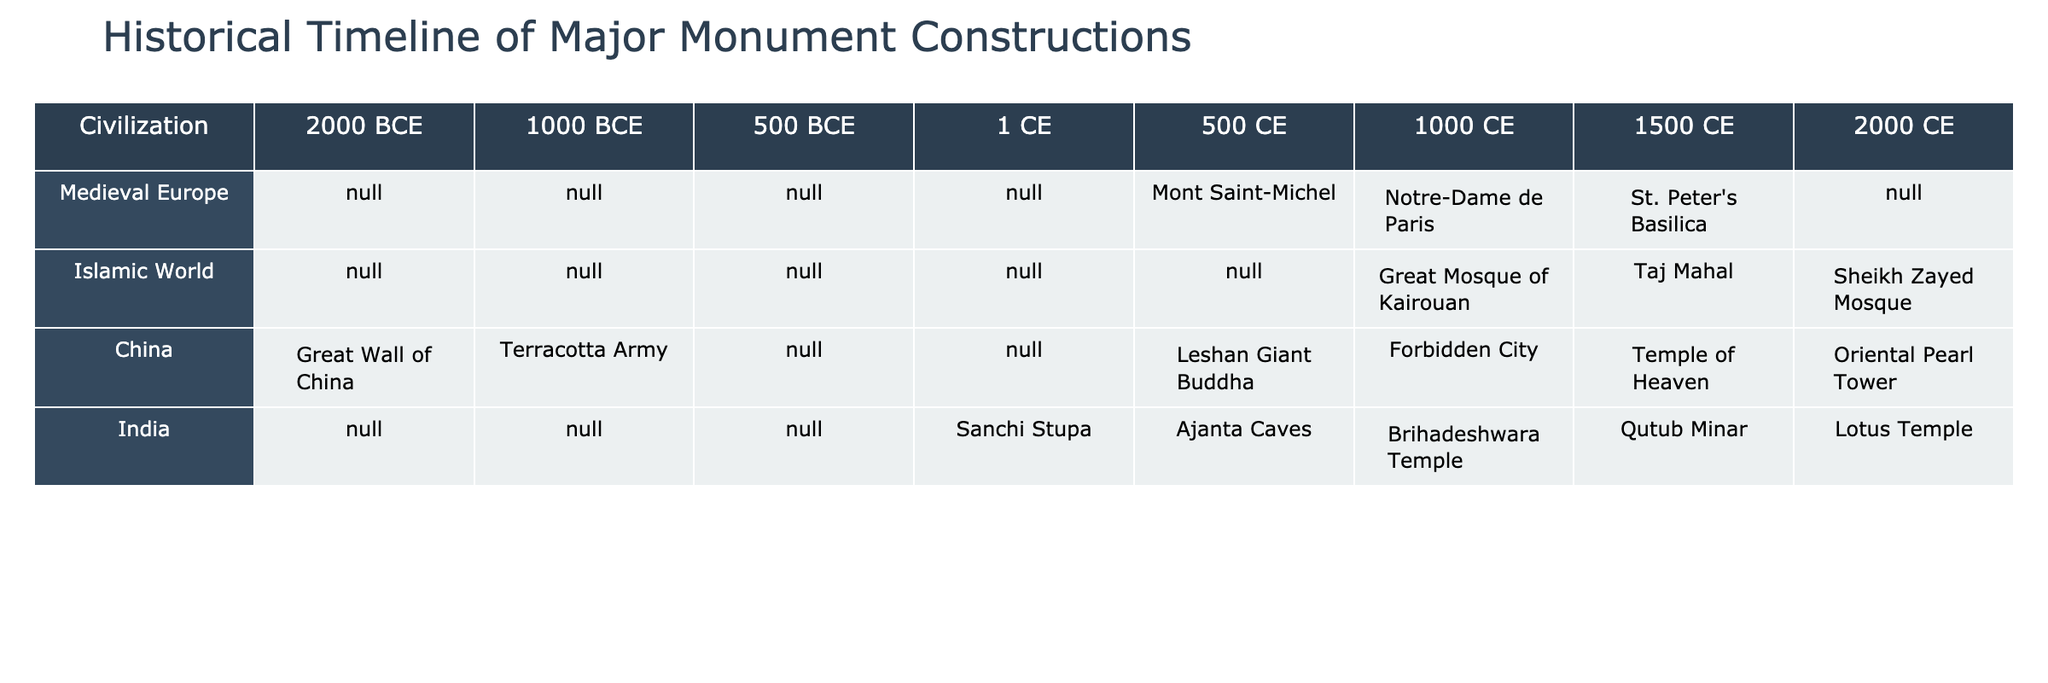What major monuments were constructed in Medieval Europe around 1000 CE? The table indicates that in Medieval Europe, the major monuments constructed around 1000 CE include Mont Saint-Michel.
Answer: Mont Saint-Michel Which civilization has the earliest recorded monument in this table? The table shows that the Great Wall of China was constructed around 2000 BCE, making it the earliest recorded monument in this timeline.
Answer: Great Wall of China Is the Taj Mahal listed as a monument from the Islamic World? The table lists the Taj Mahal as a major monument constructed in the Islamic World during the 1500 CE period.
Answer: Yes What monuments were constructed in China during the 500 CE period? According to the table, no monuments are recorded for China during the 500 CE period, which indicates a gap in monument construction during that time.
Answer: None How many monuments are recorded for India from 500 CE to 2000 CE? The monuments listed for India within that period include Sanchi Stupa, Ajanta Caves, Brihadeshwara Temple, Qutub Minar, and Lotus Temple, totaling five monuments.
Answer: Five Which civilization had the greatest number of recorded monuments in the 1000 CE period? By comparing the entries, the Islamic World has more recorded monuments (Great Mosque of Kairouan) than others.
Answer: Islamic World What is the difference in the number of monuments between China and Medieval Europe during the 1500 CE period? In the 1500 CE period, China has one monument (Temple of Heaven) while Medieval Europe also has one (St. Peter’s Basilica). Thus, the difference is zero.
Answer: Zero Which civilization constructed the Terracotta Army, and in what time period was it constructed? The Terracotta Army was constructed in China around 1000 BCE, as indicated in the table.
Answer: China, 1000 BCE Are there any monuments from the Medieval Europe that were constructed before 1000 CE? The table shows no entries for Medieval Europe before 1000 CE, indicating no recorded monuments from that civilization in earlier periods.
Answer: No What is the last major monument constructed in the Islamic World according to the table? The last major monument recorded in the Islamic World in this table is the Sheikh Zayed Mosque, constructed in the 2000 CE period.
Answer: Sheikh Zayed Mosque Which civilizations have monuments listed for the year 1 CE? The table shows that there are no monuments listed for any civilization at the year 1 CE, indicating a lack of recorded constructions during that time.
Answer: None 